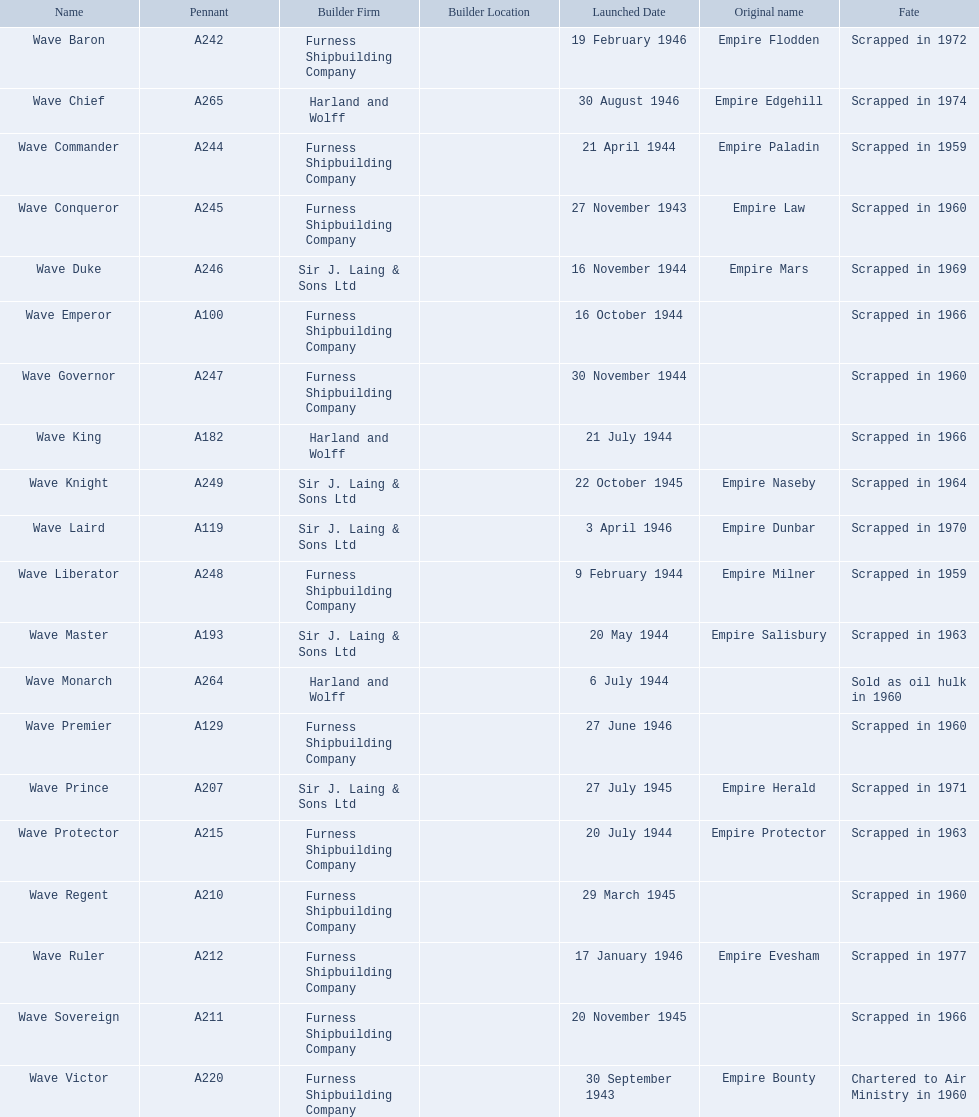What builders launched ships in november of any year? Furness Shipbuilding Company, Sir J. Laing & Sons Ltd, Furness Shipbuilding Company, Furness Shipbuilding Company. What ship builders ships had their original name's changed prior to scrapping? Furness Shipbuilding Company, Sir J. Laing & Sons Ltd. What was the name of the ship that was built in november and had its name changed prior to scrapping only 12 years after its launch? Wave Conqueror. 